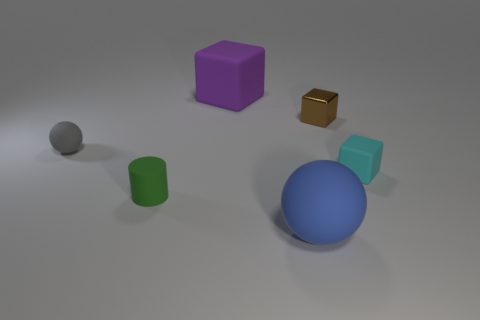Add 1 tiny yellow shiny cylinders. How many objects exist? 7 Subtract all cylinders. How many objects are left? 5 Add 6 gray rubber spheres. How many gray rubber spheres exist? 7 Subtract 1 brown blocks. How many objects are left? 5 Subtract all small yellow rubber blocks. Subtract all blue rubber balls. How many objects are left? 5 Add 2 small gray balls. How many small gray balls are left? 3 